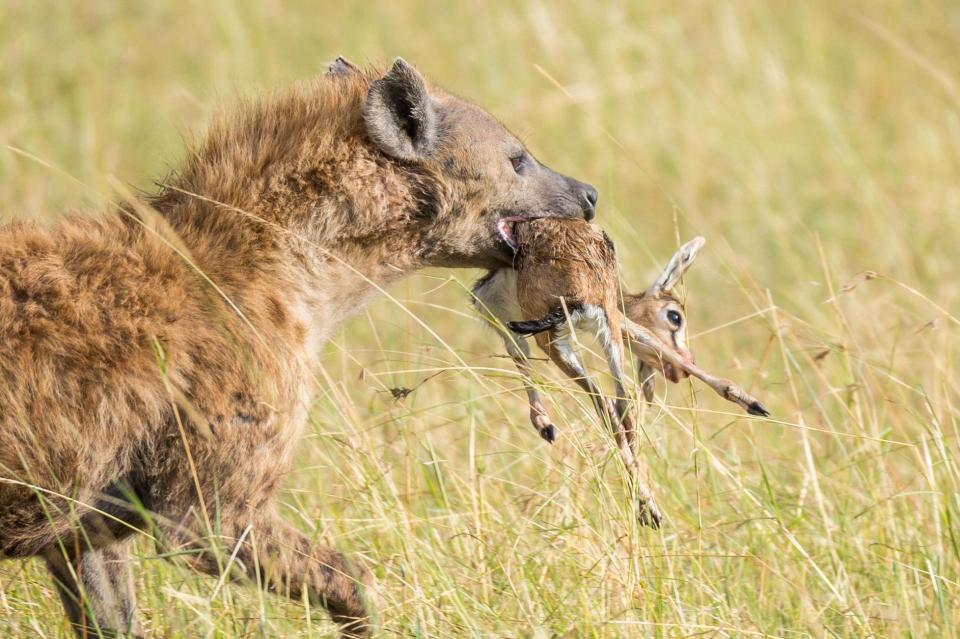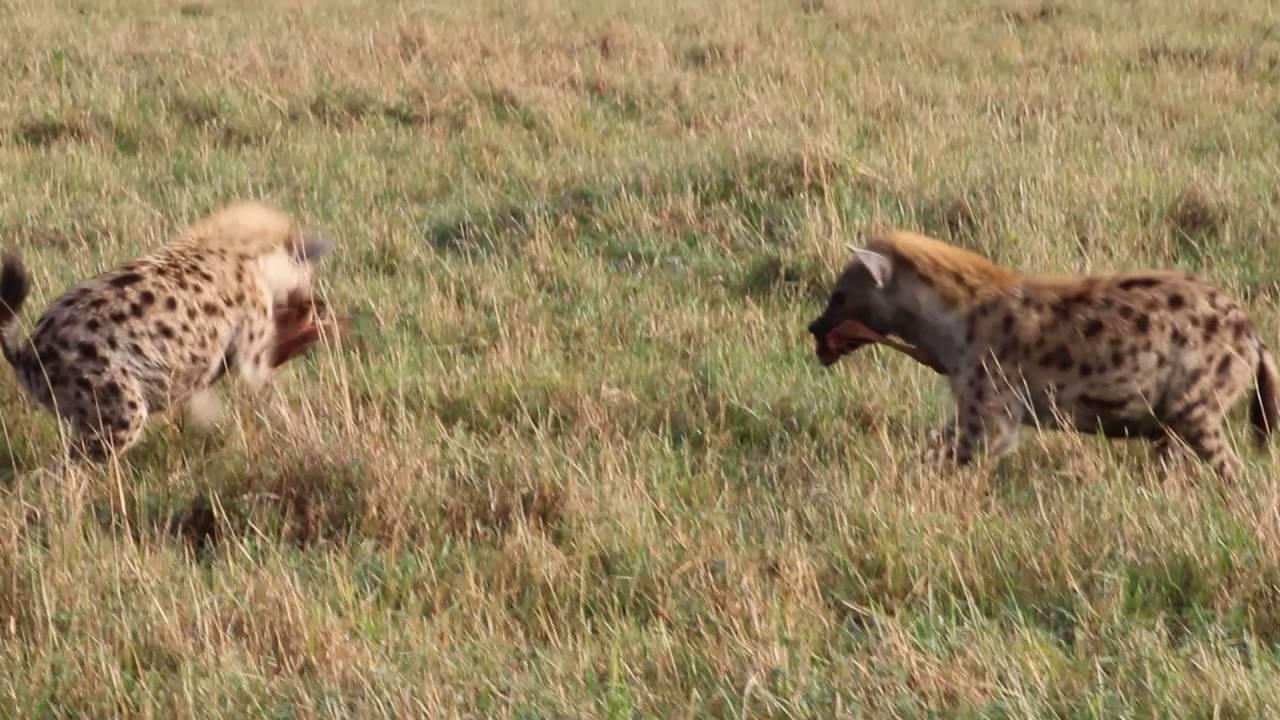The first image is the image on the left, the second image is the image on the right. Examine the images to the left and right. Is the description "The hyena in the image on the left is carrying a small animal in its mouth." accurate? Answer yes or no. Yes. The first image is the image on the left, the second image is the image on the right. Assess this claim about the two images: "An image shows one hyena, which is walking with at least part of an animal in its mouth.". Correct or not? Answer yes or no. Yes. 